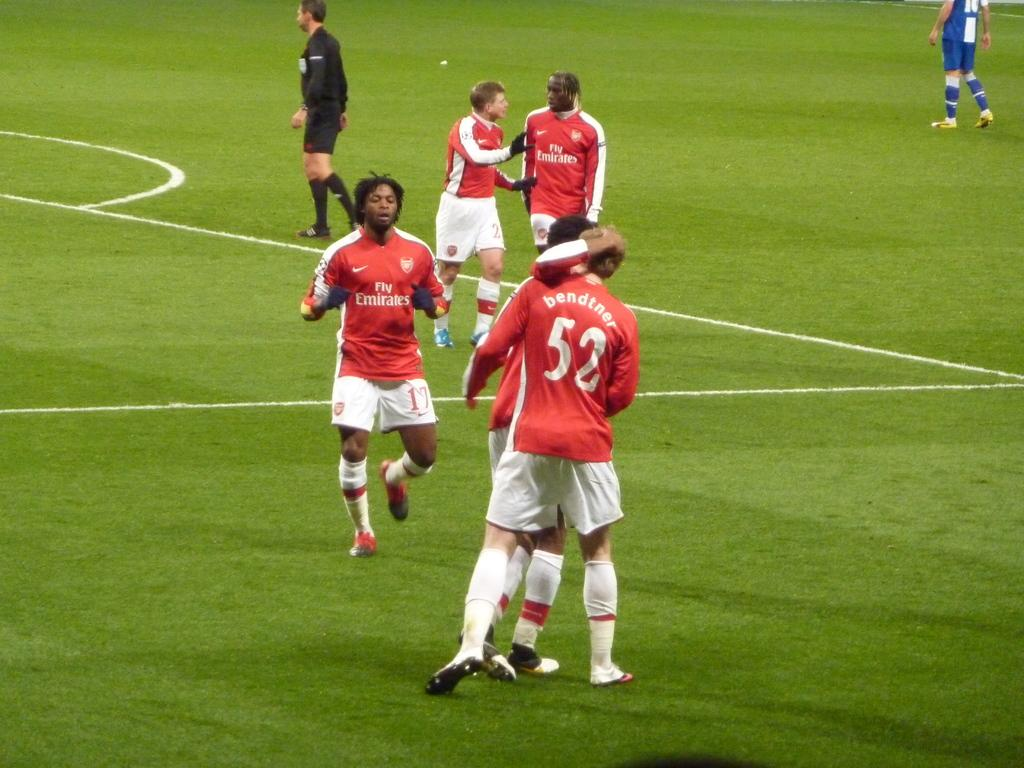<image>
Share a concise interpretation of the image provided. a football game, one man is wearing a number 52 shirt 